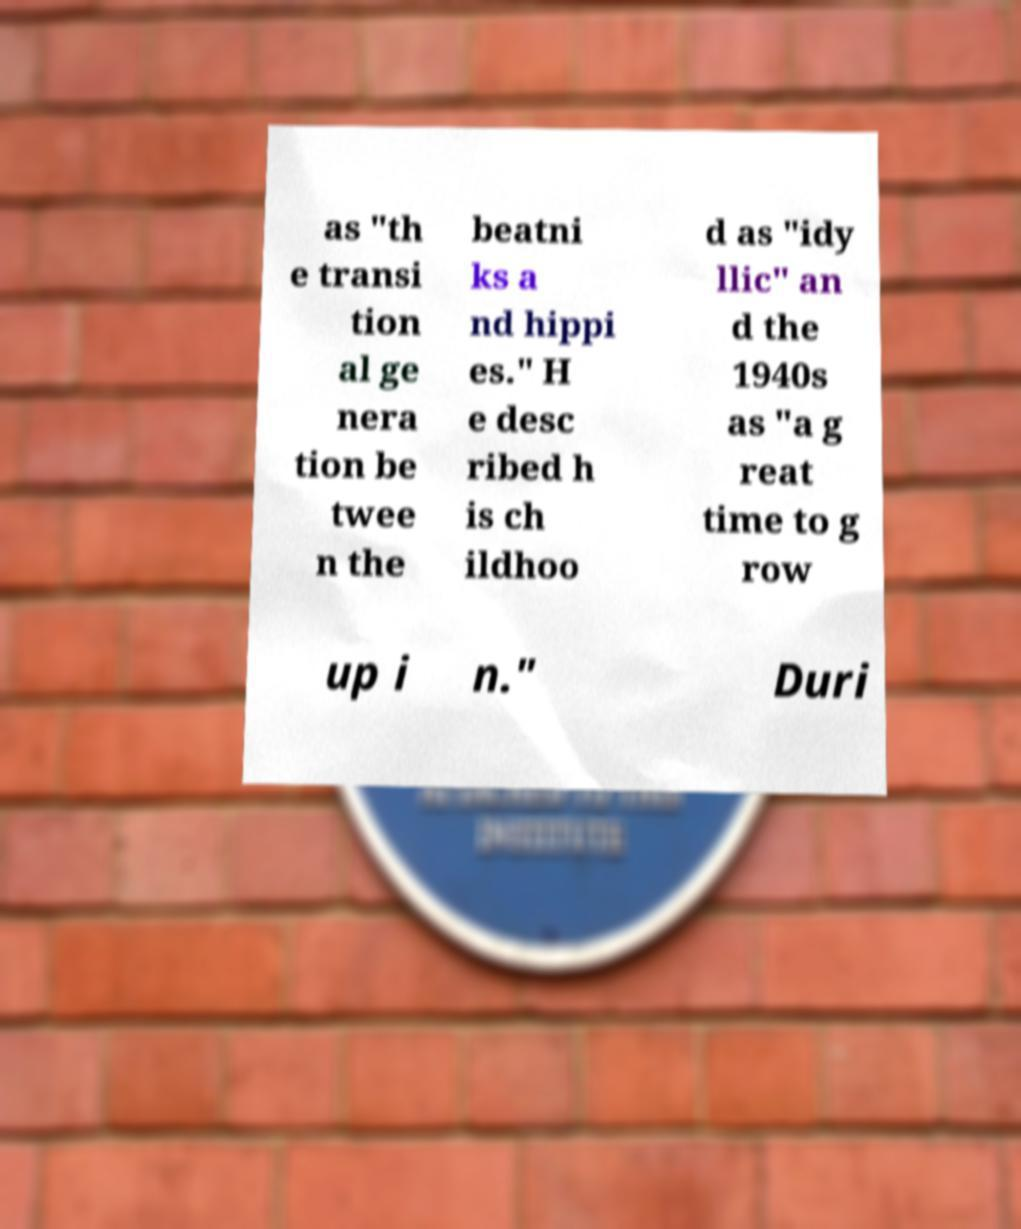I need the written content from this picture converted into text. Can you do that? as "th e transi tion al ge nera tion be twee n the beatni ks a nd hippi es." H e desc ribed h is ch ildhoo d as "idy llic" an d the 1940s as "a g reat time to g row up i n." Duri 